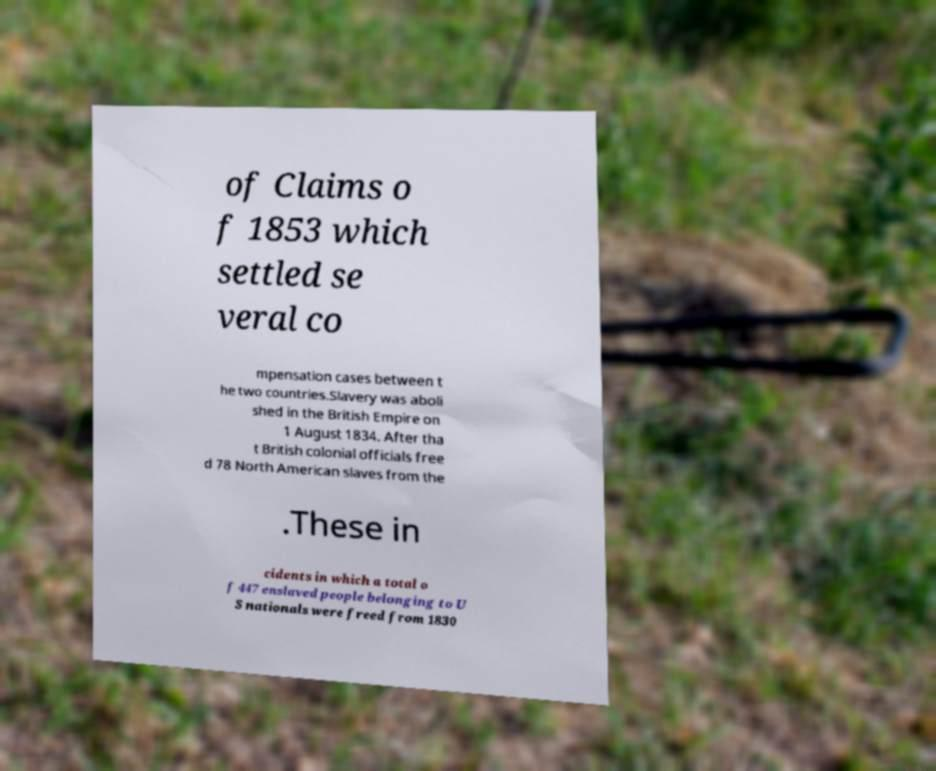Could you extract and type out the text from this image? of Claims o f 1853 which settled se veral co mpensation cases between t he two countries.Slavery was aboli shed in the British Empire on 1 August 1834. After tha t British colonial officials free d 78 North American slaves from the .These in cidents in which a total o f 447 enslaved people belonging to U S nationals were freed from 1830 